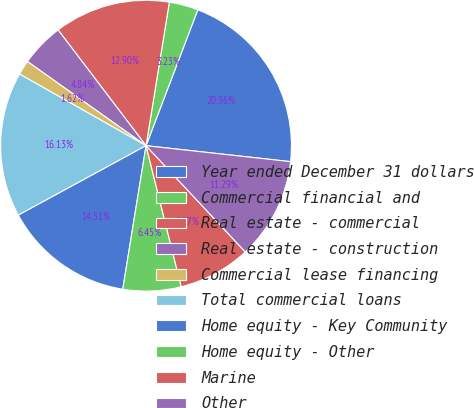<chart> <loc_0><loc_0><loc_500><loc_500><pie_chart><fcel>Year ended December 31 dollars<fcel>Commercial financial and<fcel>Real estate - commercial<fcel>Real estate - construction<fcel>Commercial lease financing<fcel>Total commercial loans<fcel>Home equity - Key Community<fcel>Home equity - Other<fcel>Marine<fcel>Other<nl><fcel>20.96%<fcel>3.23%<fcel>12.9%<fcel>4.84%<fcel>1.62%<fcel>16.13%<fcel>14.51%<fcel>6.45%<fcel>8.07%<fcel>11.29%<nl></chart> 